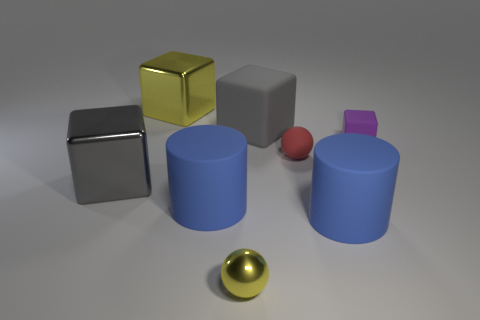How many objects are either big matte cubes or large cubes behind the small cube?
Offer a terse response. 2. There is a gray rubber object that is behind the tiny object in front of the matte ball; what size is it?
Offer a very short reply. Large. Are there the same number of big things that are to the left of the big rubber cube and gray cubes that are in front of the tiny block?
Your answer should be compact. No. There is a sphere behind the small yellow shiny thing; is there a big cylinder to the right of it?
Give a very brief answer. Yes. What is the shape of the large gray object that is the same material as the small purple object?
Make the answer very short. Cube. Is there anything else that has the same color as the rubber ball?
Your response must be concise. No. What material is the yellow thing in front of the large cube to the right of the yellow block?
Your answer should be very brief. Metal. Are there any big matte objects of the same shape as the small purple thing?
Offer a very short reply. Yes. How many other things are the same shape as the red matte object?
Ensure brevity in your answer.  1. The thing that is both in front of the gray metallic block and to the left of the tiny yellow ball has what shape?
Give a very brief answer. Cylinder. 